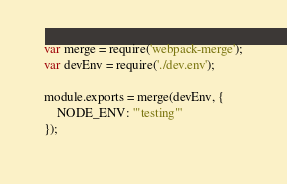<code> <loc_0><loc_0><loc_500><loc_500><_JavaScript_>var merge = require('webpack-merge');
var devEnv = require('./dev.env');

module.exports = merge(devEnv, {
    NODE_ENV: '"testing"'
});
</code> 